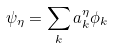<formula> <loc_0><loc_0><loc_500><loc_500>\psi _ { \eta } = \sum _ { k } a _ { k } ^ { \eta } \phi _ { k }</formula> 